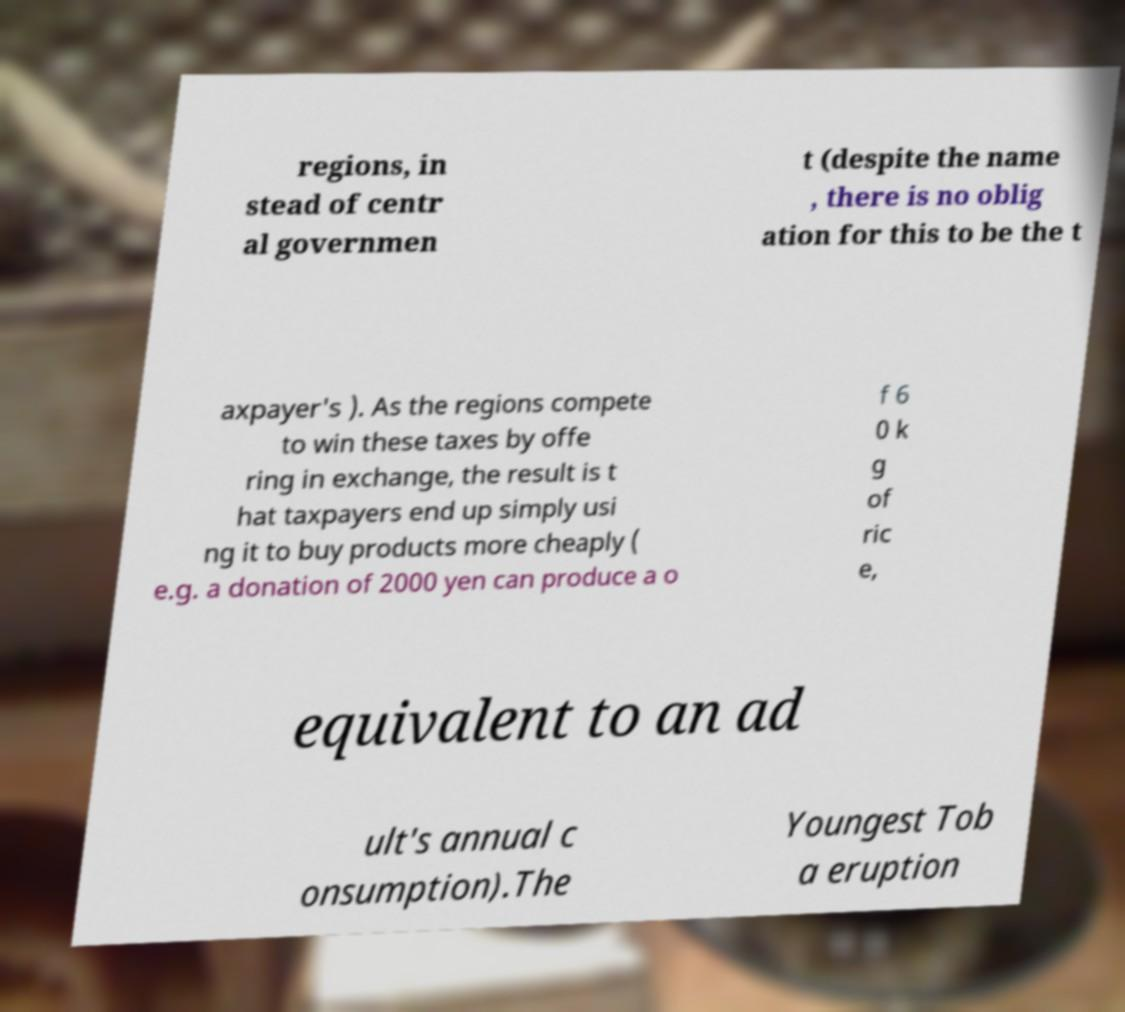Can you read and provide the text displayed in the image?This photo seems to have some interesting text. Can you extract and type it out for me? regions, in stead of centr al governmen t (despite the name , there is no oblig ation for this to be the t axpayer's ). As the regions compete to win these taxes by offe ring in exchange, the result is t hat taxpayers end up simply usi ng it to buy products more cheaply ( e.g. a donation of 2000 yen can produce a o f 6 0 k g of ric e, equivalent to an ad ult's annual c onsumption).The Youngest Tob a eruption 